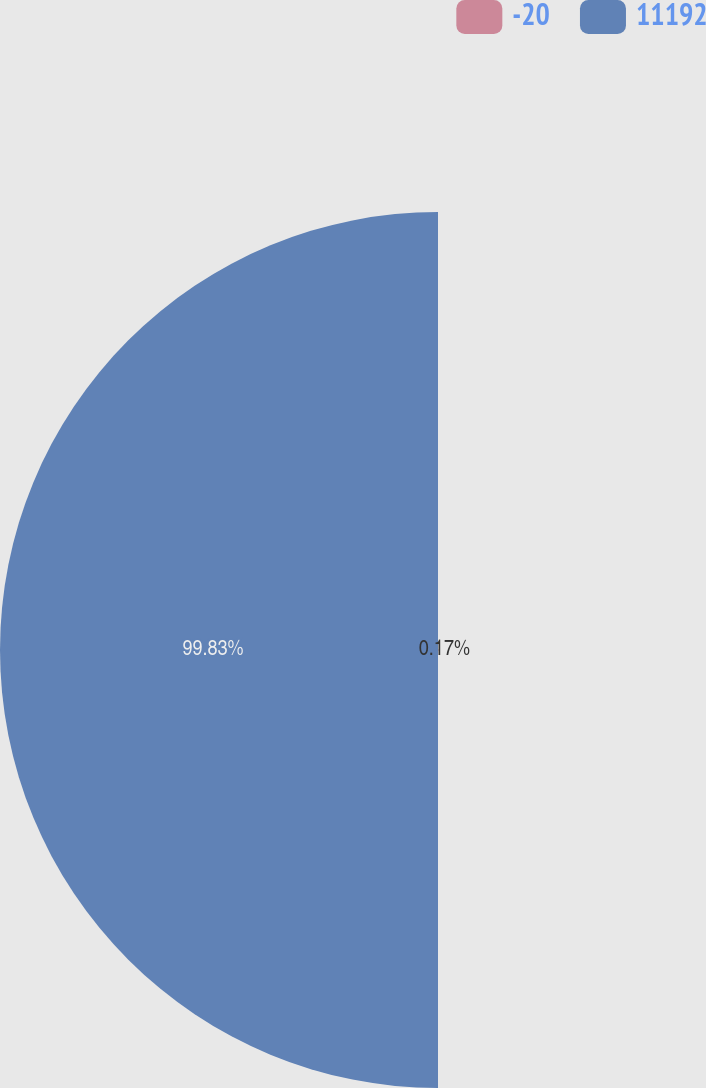<chart> <loc_0><loc_0><loc_500><loc_500><pie_chart><fcel>-20<fcel>11192<nl><fcel>0.17%<fcel>99.83%<nl></chart> 